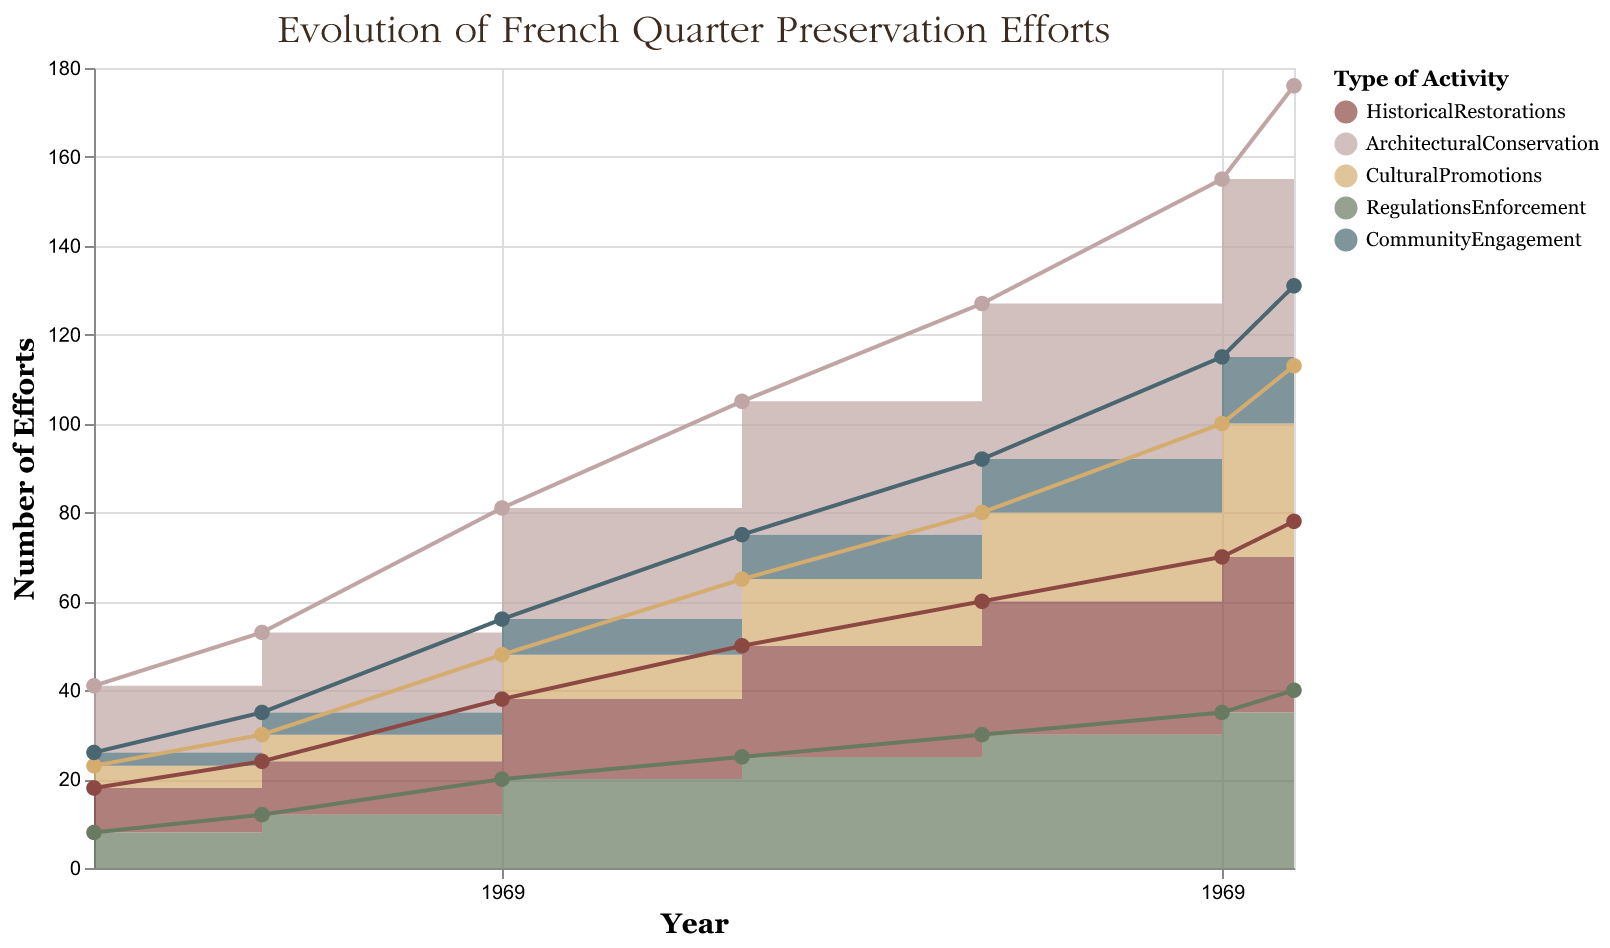What is the title of the chart? The title of the chart is usually prominently displayed at the top. It provides a summary of what the chart is about.
Answer: Evolution of French Quarter Preservation Efforts How many types of activities are represented in the chart? The legend on the right side of the chart shows different colors, each representing a type of activity. By counting the items in the legend, we can determine the number of different activities.
Answer: Five What is the color used to represent 'Cultural Promotions'? The legend associates each activity type with a specific color. By looking at the legend, we identify the color assigned to 'Cultural Promotions'.
Answer: Brown How did the number of 'Architectural Conservation' activities change between 1973 and 2023? Looking at the points for 'Architectural Conservation' at the years 1973 and 2023, we see that the number started at 15 in 1973 and increased to 45 by 2023.
Answer: Increased by 30 Which type of activity shows the highest number of efforts in 2023? By observing the endpoints of the stacked areas in 2023, the topmost layer represents the highest quantity.
Answer: Architectural Conservation Comparing 'Historical Restorations' and 'Community Engagement', which had more efforts in 2010? By examining the values of 'Historical Restorations' and 'Community Engagement' at the year 2010, we compare the heights of their respective bands.
Answer: Historical Restorations What was the total number of efforts (of all types) in 2000? To find the total, we sum the values of all types of activities for the year 2000: 25 (HistoricalRestorations) + 30 (ArchitecturalConservation) + 15 (CulturalPromotions) + 25 (RegulationsEnforcement) + 10 (CommunityEngagement).
Answer: 105 Between which consecutive years did 'Cultural Promotions' show the greatest increase? By inspecting the difference in height for 'Cultural Promotions' between each pair of consecutive years, we see the biggest gap.
Answer: 2010 to 2020 How has the trend in 'Regulations Enforcement' changed over the 50 years? Examining the 'Regulations Enforcement' area, we observe its pattern over time. Initially, it increases steadily, reflecting growing attention, with some periods showing steeper increases.
Answer: Gradually increased 